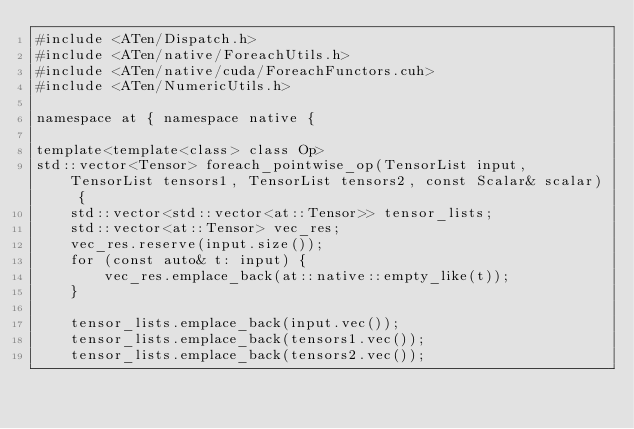Convert code to text. <code><loc_0><loc_0><loc_500><loc_500><_Cuda_>#include <ATen/Dispatch.h>
#include <ATen/native/ForeachUtils.h>
#include <ATen/native/cuda/ForeachFunctors.cuh>
#include <ATen/NumericUtils.h>

namespace at { namespace native {

template<template<class> class Op>
std::vector<Tensor> foreach_pointwise_op(TensorList input, TensorList tensors1, TensorList tensors2, const Scalar& scalar) {
    std::vector<std::vector<at::Tensor>> tensor_lists;
    std::vector<at::Tensor> vec_res;
    vec_res.reserve(input.size());
    for (const auto& t: input) {
        vec_res.emplace_back(at::native::empty_like(t));
    }

    tensor_lists.emplace_back(input.vec());
    tensor_lists.emplace_back(tensors1.vec());
    tensor_lists.emplace_back(tensors2.vec());</code> 